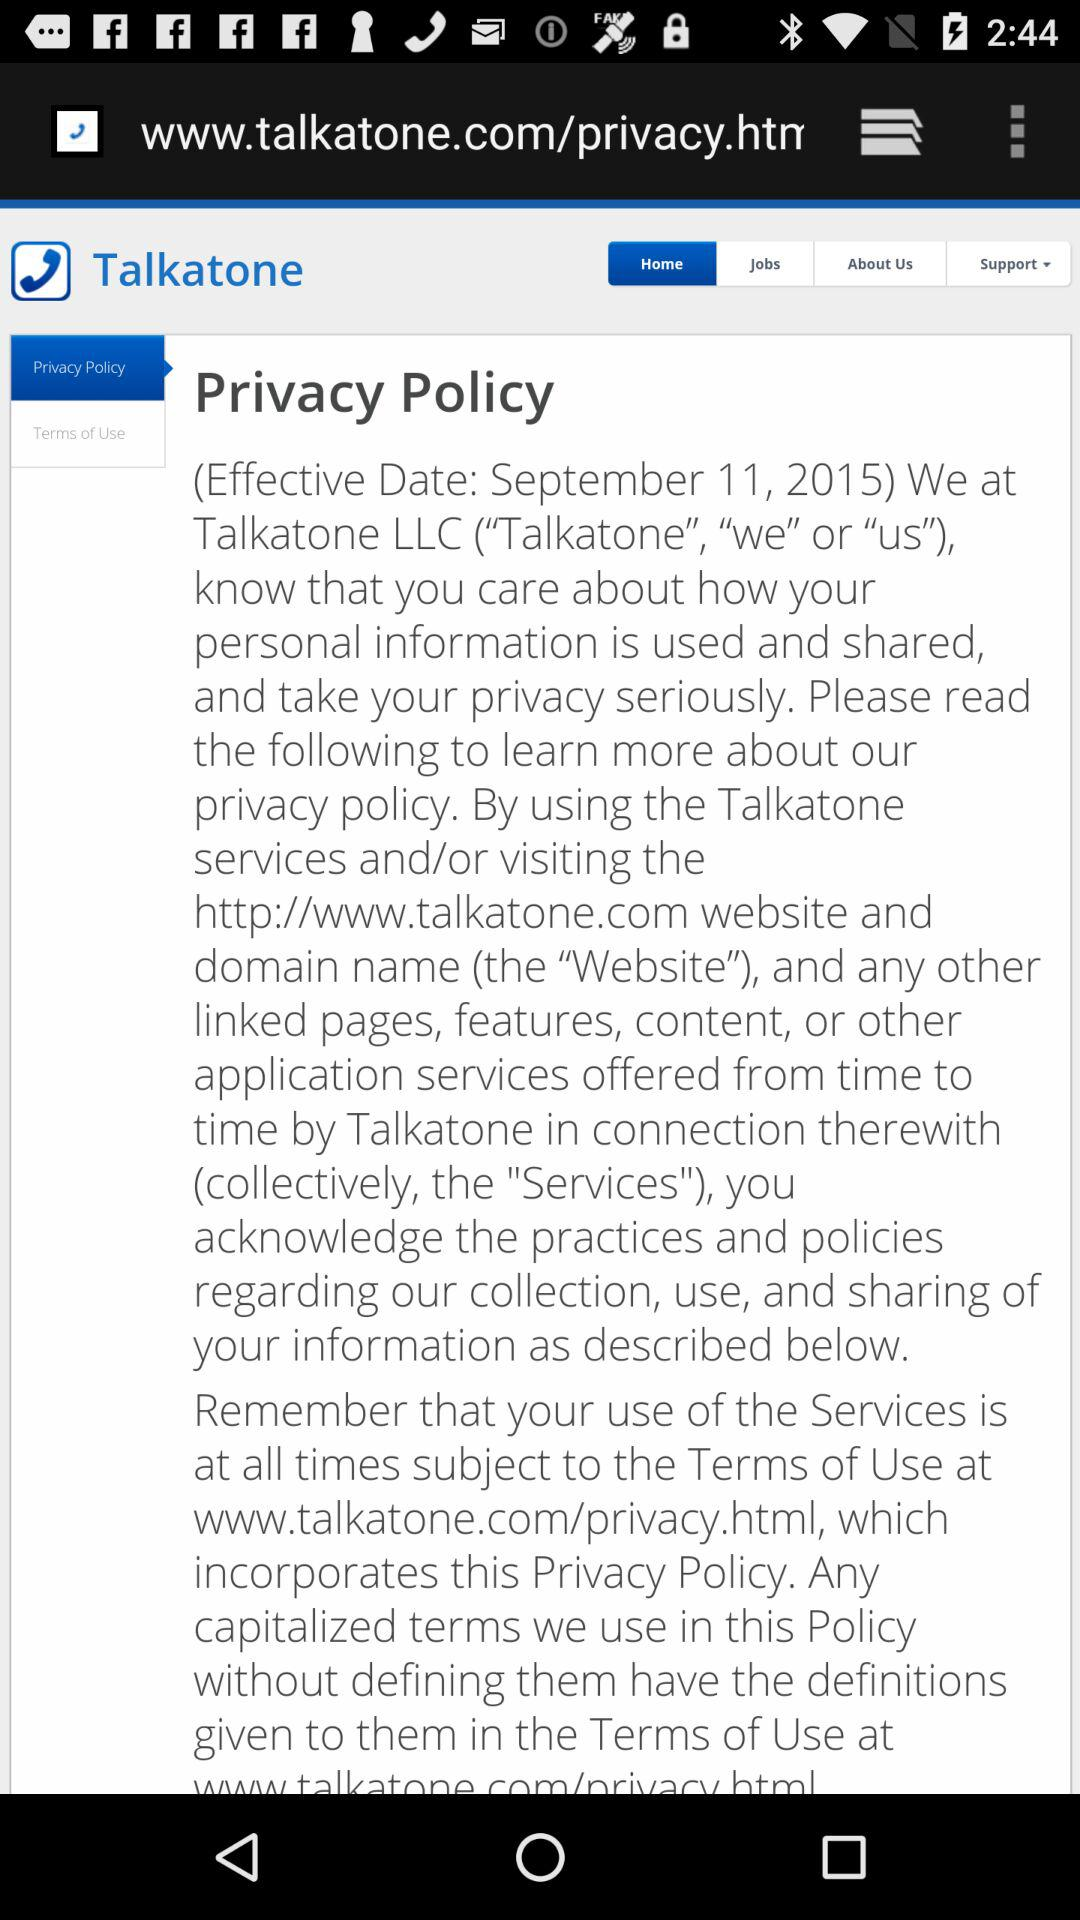What is the app name? The app name is "Talkatone". 